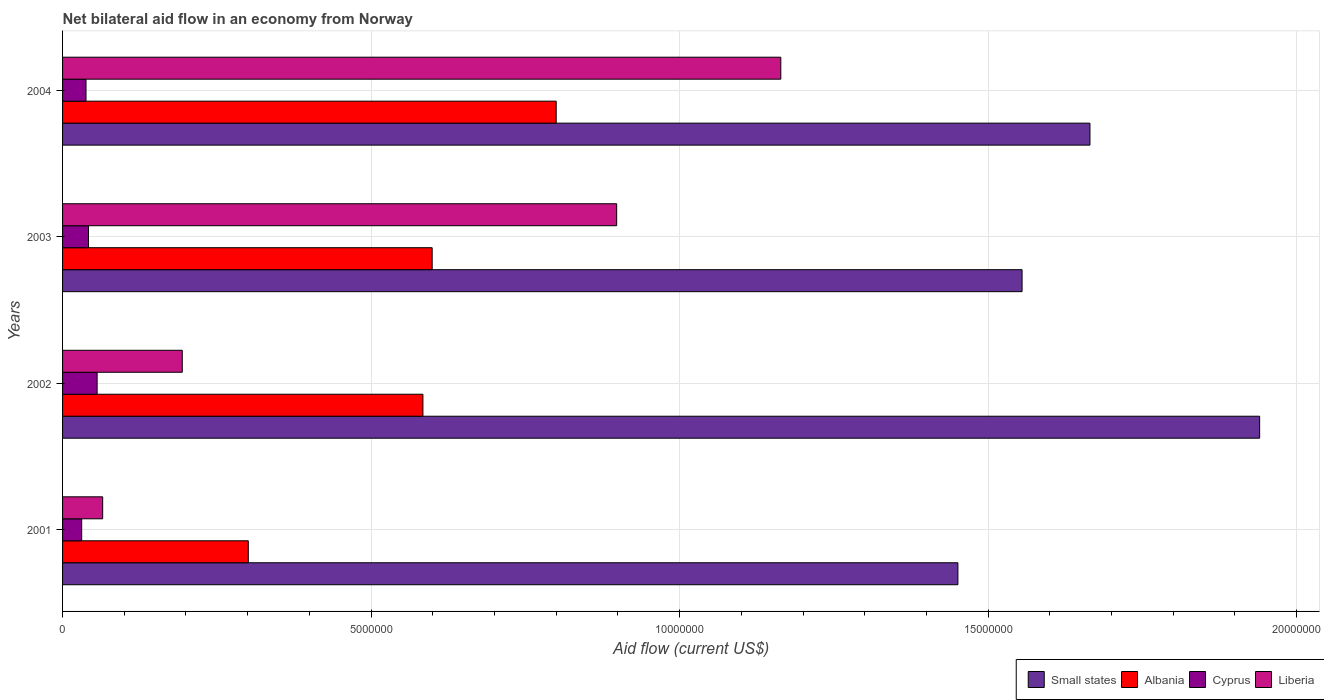How many different coloured bars are there?
Provide a succinct answer. 4. Are the number of bars on each tick of the Y-axis equal?
Your response must be concise. Yes. How many bars are there on the 4th tick from the top?
Offer a terse response. 4. How many bars are there on the 4th tick from the bottom?
Give a very brief answer. 4. What is the net bilateral aid flow in Albania in 2003?
Offer a terse response. 5.99e+06. Across all years, what is the minimum net bilateral aid flow in Albania?
Your answer should be compact. 3.01e+06. What is the total net bilateral aid flow in Albania in the graph?
Make the answer very short. 2.28e+07. What is the difference between the net bilateral aid flow in Small states in 2001 and that in 2003?
Your answer should be compact. -1.04e+06. What is the difference between the net bilateral aid flow in Small states in 2004 and the net bilateral aid flow in Liberia in 2003?
Ensure brevity in your answer.  7.67e+06. What is the average net bilateral aid flow in Cyprus per year?
Offer a terse response. 4.18e+05. In the year 2004, what is the difference between the net bilateral aid flow in Small states and net bilateral aid flow in Albania?
Your answer should be very brief. 8.65e+06. What is the ratio of the net bilateral aid flow in Liberia in 2003 to that in 2004?
Your response must be concise. 0.77. Is the net bilateral aid flow in Liberia in 2001 less than that in 2004?
Provide a succinct answer. Yes. What is the difference between the highest and the second highest net bilateral aid flow in Liberia?
Keep it short and to the point. 2.66e+06. In how many years, is the net bilateral aid flow in Small states greater than the average net bilateral aid flow in Small states taken over all years?
Give a very brief answer. 2. What does the 4th bar from the top in 2004 represents?
Your response must be concise. Small states. What does the 3rd bar from the bottom in 2001 represents?
Ensure brevity in your answer.  Cyprus. How many bars are there?
Your response must be concise. 16. Are all the bars in the graph horizontal?
Provide a short and direct response. Yes. Does the graph contain any zero values?
Your response must be concise. No. Where does the legend appear in the graph?
Offer a very short reply. Bottom right. What is the title of the graph?
Your response must be concise. Net bilateral aid flow in an economy from Norway. Does "Cayman Islands" appear as one of the legend labels in the graph?
Give a very brief answer. No. What is the Aid flow (current US$) of Small states in 2001?
Give a very brief answer. 1.45e+07. What is the Aid flow (current US$) in Albania in 2001?
Provide a succinct answer. 3.01e+06. What is the Aid flow (current US$) of Liberia in 2001?
Provide a succinct answer. 6.50e+05. What is the Aid flow (current US$) in Small states in 2002?
Your answer should be compact. 1.94e+07. What is the Aid flow (current US$) of Albania in 2002?
Keep it short and to the point. 5.84e+06. What is the Aid flow (current US$) in Cyprus in 2002?
Your answer should be compact. 5.60e+05. What is the Aid flow (current US$) of Liberia in 2002?
Your answer should be very brief. 1.94e+06. What is the Aid flow (current US$) in Small states in 2003?
Give a very brief answer. 1.56e+07. What is the Aid flow (current US$) in Albania in 2003?
Offer a terse response. 5.99e+06. What is the Aid flow (current US$) in Cyprus in 2003?
Offer a terse response. 4.20e+05. What is the Aid flow (current US$) in Liberia in 2003?
Ensure brevity in your answer.  8.98e+06. What is the Aid flow (current US$) in Small states in 2004?
Your response must be concise. 1.66e+07. What is the Aid flow (current US$) of Cyprus in 2004?
Offer a very short reply. 3.80e+05. What is the Aid flow (current US$) in Liberia in 2004?
Your answer should be very brief. 1.16e+07. Across all years, what is the maximum Aid flow (current US$) of Small states?
Provide a succinct answer. 1.94e+07. Across all years, what is the maximum Aid flow (current US$) in Albania?
Offer a terse response. 8.00e+06. Across all years, what is the maximum Aid flow (current US$) in Cyprus?
Provide a short and direct response. 5.60e+05. Across all years, what is the maximum Aid flow (current US$) in Liberia?
Offer a very short reply. 1.16e+07. Across all years, what is the minimum Aid flow (current US$) in Small states?
Ensure brevity in your answer.  1.45e+07. Across all years, what is the minimum Aid flow (current US$) in Albania?
Keep it short and to the point. 3.01e+06. Across all years, what is the minimum Aid flow (current US$) in Liberia?
Offer a terse response. 6.50e+05. What is the total Aid flow (current US$) of Small states in the graph?
Your answer should be compact. 6.61e+07. What is the total Aid flow (current US$) in Albania in the graph?
Your response must be concise. 2.28e+07. What is the total Aid flow (current US$) in Cyprus in the graph?
Keep it short and to the point. 1.67e+06. What is the total Aid flow (current US$) in Liberia in the graph?
Provide a short and direct response. 2.32e+07. What is the difference between the Aid flow (current US$) of Small states in 2001 and that in 2002?
Ensure brevity in your answer.  -4.89e+06. What is the difference between the Aid flow (current US$) of Albania in 2001 and that in 2002?
Your response must be concise. -2.83e+06. What is the difference between the Aid flow (current US$) in Liberia in 2001 and that in 2002?
Your answer should be compact. -1.29e+06. What is the difference between the Aid flow (current US$) of Small states in 2001 and that in 2003?
Make the answer very short. -1.04e+06. What is the difference between the Aid flow (current US$) of Albania in 2001 and that in 2003?
Provide a short and direct response. -2.98e+06. What is the difference between the Aid flow (current US$) in Cyprus in 2001 and that in 2003?
Keep it short and to the point. -1.10e+05. What is the difference between the Aid flow (current US$) of Liberia in 2001 and that in 2003?
Offer a terse response. -8.33e+06. What is the difference between the Aid flow (current US$) in Small states in 2001 and that in 2004?
Provide a succinct answer. -2.14e+06. What is the difference between the Aid flow (current US$) in Albania in 2001 and that in 2004?
Your response must be concise. -4.99e+06. What is the difference between the Aid flow (current US$) of Liberia in 2001 and that in 2004?
Provide a succinct answer. -1.10e+07. What is the difference between the Aid flow (current US$) in Small states in 2002 and that in 2003?
Your answer should be very brief. 3.85e+06. What is the difference between the Aid flow (current US$) in Albania in 2002 and that in 2003?
Your answer should be compact. -1.50e+05. What is the difference between the Aid flow (current US$) of Cyprus in 2002 and that in 2003?
Provide a succinct answer. 1.40e+05. What is the difference between the Aid flow (current US$) of Liberia in 2002 and that in 2003?
Your answer should be very brief. -7.04e+06. What is the difference between the Aid flow (current US$) in Small states in 2002 and that in 2004?
Your answer should be very brief. 2.75e+06. What is the difference between the Aid flow (current US$) of Albania in 2002 and that in 2004?
Provide a succinct answer. -2.16e+06. What is the difference between the Aid flow (current US$) in Liberia in 2002 and that in 2004?
Offer a terse response. -9.70e+06. What is the difference between the Aid flow (current US$) in Small states in 2003 and that in 2004?
Make the answer very short. -1.10e+06. What is the difference between the Aid flow (current US$) in Albania in 2003 and that in 2004?
Your answer should be very brief. -2.01e+06. What is the difference between the Aid flow (current US$) of Liberia in 2003 and that in 2004?
Give a very brief answer. -2.66e+06. What is the difference between the Aid flow (current US$) in Small states in 2001 and the Aid flow (current US$) in Albania in 2002?
Offer a very short reply. 8.67e+06. What is the difference between the Aid flow (current US$) of Small states in 2001 and the Aid flow (current US$) of Cyprus in 2002?
Your answer should be very brief. 1.40e+07. What is the difference between the Aid flow (current US$) of Small states in 2001 and the Aid flow (current US$) of Liberia in 2002?
Your answer should be very brief. 1.26e+07. What is the difference between the Aid flow (current US$) in Albania in 2001 and the Aid flow (current US$) in Cyprus in 2002?
Provide a succinct answer. 2.45e+06. What is the difference between the Aid flow (current US$) in Albania in 2001 and the Aid flow (current US$) in Liberia in 2002?
Make the answer very short. 1.07e+06. What is the difference between the Aid flow (current US$) of Cyprus in 2001 and the Aid flow (current US$) of Liberia in 2002?
Make the answer very short. -1.63e+06. What is the difference between the Aid flow (current US$) of Small states in 2001 and the Aid flow (current US$) of Albania in 2003?
Keep it short and to the point. 8.52e+06. What is the difference between the Aid flow (current US$) of Small states in 2001 and the Aid flow (current US$) of Cyprus in 2003?
Your answer should be compact. 1.41e+07. What is the difference between the Aid flow (current US$) in Small states in 2001 and the Aid flow (current US$) in Liberia in 2003?
Make the answer very short. 5.53e+06. What is the difference between the Aid flow (current US$) in Albania in 2001 and the Aid flow (current US$) in Cyprus in 2003?
Your response must be concise. 2.59e+06. What is the difference between the Aid flow (current US$) of Albania in 2001 and the Aid flow (current US$) of Liberia in 2003?
Your response must be concise. -5.97e+06. What is the difference between the Aid flow (current US$) in Cyprus in 2001 and the Aid flow (current US$) in Liberia in 2003?
Ensure brevity in your answer.  -8.67e+06. What is the difference between the Aid flow (current US$) of Small states in 2001 and the Aid flow (current US$) of Albania in 2004?
Your answer should be very brief. 6.51e+06. What is the difference between the Aid flow (current US$) in Small states in 2001 and the Aid flow (current US$) in Cyprus in 2004?
Provide a short and direct response. 1.41e+07. What is the difference between the Aid flow (current US$) of Small states in 2001 and the Aid flow (current US$) of Liberia in 2004?
Ensure brevity in your answer.  2.87e+06. What is the difference between the Aid flow (current US$) of Albania in 2001 and the Aid flow (current US$) of Cyprus in 2004?
Your answer should be compact. 2.63e+06. What is the difference between the Aid flow (current US$) of Albania in 2001 and the Aid flow (current US$) of Liberia in 2004?
Ensure brevity in your answer.  -8.63e+06. What is the difference between the Aid flow (current US$) of Cyprus in 2001 and the Aid flow (current US$) of Liberia in 2004?
Offer a very short reply. -1.13e+07. What is the difference between the Aid flow (current US$) of Small states in 2002 and the Aid flow (current US$) of Albania in 2003?
Make the answer very short. 1.34e+07. What is the difference between the Aid flow (current US$) of Small states in 2002 and the Aid flow (current US$) of Cyprus in 2003?
Provide a short and direct response. 1.90e+07. What is the difference between the Aid flow (current US$) of Small states in 2002 and the Aid flow (current US$) of Liberia in 2003?
Offer a terse response. 1.04e+07. What is the difference between the Aid flow (current US$) in Albania in 2002 and the Aid flow (current US$) in Cyprus in 2003?
Your answer should be compact. 5.42e+06. What is the difference between the Aid flow (current US$) in Albania in 2002 and the Aid flow (current US$) in Liberia in 2003?
Make the answer very short. -3.14e+06. What is the difference between the Aid flow (current US$) in Cyprus in 2002 and the Aid flow (current US$) in Liberia in 2003?
Keep it short and to the point. -8.42e+06. What is the difference between the Aid flow (current US$) of Small states in 2002 and the Aid flow (current US$) of Albania in 2004?
Offer a very short reply. 1.14e+07. What is the difference between the Aid flow (current US$) in Small states in 2002 and the Aid flow (current US$) in Cyprus in 2004?
Make the answer very short. 1.90e+07. What is the difference between the Aid flow (current US$) in Small states in 2002 and the Aid flow (current US$) in Liberia in 2004?
Make the answer very short. 7.76e+06. What is the difference between the Aid flow (current US$) of Albania in 2002 and the Aid flow (current US$) of Cyprus in 2004?
Your answer should be compact. 5.46e+06. What is the difference between the Aid flow (current US$) in Albania in 2002 and the Aid flow (current US$) in Liberia in 2004?
Ensure brevity in your answer.  -5.80e+06. What is the difference between the Aid flow (current US$) in Cyprus in 2002 and the Aid flow (current US$) in Liberia in 2004?
Your response must be concise. -1.11e+07. What is the difference between the Aid flow (current US$) in Small states in 2003 and the Aid flow (current US$) in Albania in 2004?
Your response must be concise. 7.55e+06. What is the difference between the Aid flow (current US$) of Small states in 2003 and the Aid flow (current US$) of Cyprus in 2004?
Offer a terse response. 1.52e+07. What is the difference between the Aid flow (current US$) of Small states in 2003 and the Aid flow (current US$) of Liberia in 2004?
Your answer should be compact. 3.91e+06. What is the difference between the Aid flow (current US$) in Albania in 2003 and the Aid flow (current US$) in Cyprus in 2004?
Provide a succinct answer. 5.61e+06. What is the difference between the Aid flow (current US$) of Albania in 2003 and the Aid flow (current US$) of Liberia in 2004?
Offer a very short reply. -5.65e+06. What is the difference between the Aid flow (current US$) of Cyprus in 2003 and the Aid flow (current US$) of Liberia in 2004?
Your answer should be compact. -1.12e+07. What is the average Aid flow (current US$) of Small states per year?
Your answer should be compact. 1.65e+07. What is the average Aid flow (current US$) in Albania per year?
Your answer should be very brief. 5.71e+06. What is the average Aid flow (current US$) in Cyprus per year?
Keep it short and to the point. 4.18e+05. What is the average Aid flow (current US$) of Liberia per year?
Your answer should be compact. 5.80e+06. In the year 2001, what is the difference between the Aid flow (current US$) in Small states and Aid flow (current US$) in Albania?
Make the answer very short. 1.15e+07. In the year 2001, what is the difference between the Aid flow (current US$) of Small states and Aid flow (current US$) of Cyprus?
Your answer should be very brief. 1.42e+07. In the year 2001, what is the difference between the Aid flow (current US$) in Small states and Aid flow (current US$) in Liberia?
Your response must be concise. 1.39e+07. In the year 2001, what is the difference between the Aid flow (current US$) of Albania and Aid flow (current US$) of Cyprus?
Your response must be concise. 2.70e+06. In the year 2001, what is the difference between the Aid flow (current US$) in Albania and Aid flow (current US$) in Liberia?
Provide a short and direct response. 2.36e+06. In the year 2001, what is the difference between the Aid flow (current US$) in Cyprus and Aid flow (current US$) in Liberia?
Provide a short and direct response. -3.40e+05. In the year 2002, what is the difference between the Aid flow (current US$) in Small states and Aid flow (current US$) in Albania?
Keep it short and to the point. 1.36e+07. In the year 2002, what is the difference between the Aid flow (current US$) in Small states and Aid flow (current US$) in Cyprus?
Offer a very short reply. 1.88e+07. In the year 2002, what is the difference between the Aid flow (current US$) in Small states and Aid flow (current US$) in Liberia?
Offer a very short reply. 1.75e+07. In the year 2002, what is the difference between the Aid flow (current US$) in Albania and Aid flow (current US$) in Cyprus?
Keep it short and to the point. 5.28e+06. In the year 2002, what is the difference between the Aid flow (current US$) of Albania and Aid flow (current US$) of Liberia?
Offer a terse response. 3.90e+06. In the year 2002, what is the difference between the Aid flow (current US$) in Cyprus and Aid flow (current US$) in Liberia?
Give a very brief answer. -1.38e+06. In the year 2003, what is the difference between the Aid flow (current US$) in Small states and Aid flow (current US$) in Albania?
Keep it short and to the point. 9.56e+06. In the year 2003, what is the difference between the Aid flow (current US$) of Small states and Aid flow (current US$) of Cyprus?
Ensure brevity in your answer.  1.51e+07. In the year 2003, what is the difference between the Aid flow (current US$) in Small states and Aid flow (current US$) in Liberia?
Your answer should be very brief. 6.57e+06. In the year 2003, what is the difference between the Aid flow (current US$) of Albania and Aid flow (current US$) of Cyprus?
Your response must be concise. 5.57e+06. In the year 2003, what is the difference between the Aid flow (current US$) in Albania and Aid flow (current US$) in Liberia?
Keep it short and to the point. -2.99e+06. In the year 2003, what is the difference between the Aid flow (current US$) of Cyprus and Aid flow (current US$) of Liberia?
Your answer should be very brief. -8.56e+06. In the year 2004, what is the difference between the Aid flow (current US$) of Small states and Aid flow (current US$) of Albania?
Offer a very short reply. 8.65e+06. In the year 2004, what is the difference between the Aid flow (current US$) of Small states and Aid flow (current US$) of Cyprus?
Keep it short and to the point. 1.63e+07. In the year 2004, what is the difference between the Aid flow (current US$) of Small states and Aid flow (current US$) of Liberia?
Offer a very short reply. 5.01e+06. In the year 2004, what is the difference between the Aid flow (current US$) in Albania and Aid flow (current US$) in Cyprus?
Keep it short and to the point. 7.62e+06. In the year 2004, what is the difference between the Aid flow (current US$) in Albania and Aid flow (current US$) in Liberia?
Your answer should be compact. -3.64e+06. In the year 2004, what is the difference between the Aid flow (current US$) of Cyprus and Aid flow (current US$) of Liberia?
Keep it short and to the point. -1.13e+07. What is the ratio of the Aid flow (current US$) in Small states in 2001 to that in 2002?
Keep it short and to the point. 0.75. What is the ratio of the Aid flow (current US$) in Albania in 2001 to that in 2002?
Give a very brief answer. 0.52. What is the ratio of the Aid flow (current US$) in Cyprus in 2001 to that in 2002?
Ensure brevity in your answer.  0.55. What is the ratio of the Aid flow (current US$) of Liberia in 2001 to that in 2002?
Offer a terse response. 0.34. What is the ratio of the Aid flow (current US$) in Small states in 2001 to that in 2003?
Provide a succinct answer. 0.93. What is the ratio of the Aid flow (current US$) in Albania in 2001 to that in 2003?
Offer a terse response. 0.5. What is the ratio of the Aid flow (current US$) of Cyprus in 2001 to that in 2003?
Keep it short and to the point. 0.74. What is the ratio of the Aid flow (current US$) in Liberia in 2001 to that in 2003?
Your answer should be compact. 0.07. What is the ratio of the Aid flow (current US$) of Small states in 2001 to that in 2004?
Your answer should be compact. 0.87. What is the ratio of the Aid flow (current US$) in Albania in 2001 to that in 2004?
Give a very brief answer. 0.38. What is the ratio of the Aid flow (current US$) of Cyprus in 2001 to that in 2004?
Make the answer very short. 0.82. What is the ratio of the Aid flow (current US$) of Liberia in 2001 to that in 2004?
Ensure brevity in your answer.  0.06. What is the ratio of the Aid flow (current US$) in Small states in 2002 to that in 2003?
Your response must be concise. 1.25. What is the ratio of the Aid flow (current US$) of Liberia in 2002 to that in 2003?
Offer a terse response. 0.22. What is the ratio of the Aid flow (current US$) of Small states in 2002 to that in 2004?
Keep it short and to the point. 1.17. What is the ratio of the Aid flow (current US$) of Albania in 2002 to that in 2004?
Your answer should be very brief. 0.73. What is the ratio of the Aid flow (current US$) of Cyprus in 2002 to that in 2004?
Your answer should be very brief. 1.47. What is the ratio of the Aid flow (current US$) of Small states in 2003 to that in 2004?
Your response must be concise. 0.93. What is the ratio of the Aid flow (current US$) of Albania in 2003 to that in 2004?
Ensure brevity in your answer.  0.75. What is the ratio of the Aid flow (current US$) in Cyprus in 2003 to that in 2004?
Provide a succinct answer. 1.11. What is the ratio of the Aid flow (current US$) of Liberia in 2003 to that in 2004?
Keep it short and to the point. 0.77. What is the difference between the highest and the second highest Aid flow (current US$) in Small states?
Ensure brevity in your answer.  2.75e+06. What is the difference between the highest and the second highest Aid flow (current US$) of Albania?
Keep it short and to the point. 2.01e+06. What is the difference between the highest and the second highest Aid flow (current US$) in Cyprus?
Your response must be concise. 1.40e+05. What is the difference between the highest and the second highest Aid flow (current US$) of Liberia?
Provide a succinct answer. 2.66e+06. What is the difference between the highest and the lowest Aid flow (current US$) in Small states?
Ensure brevity in your answer.  4.89e+06. What is the difference between the highest and the lowest Aid flow (current US$) in Albania?
Give a very brief answer. 4.99e+06. What is the difference between the highest and the lowest Aid flow (current US$) of Liberia?
Your response must be concise. 1.10e+07. 